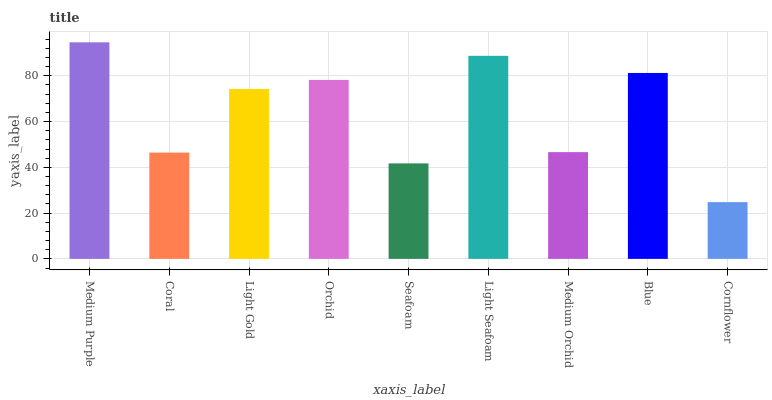Is Cornflower the minimum?
Answer yes or no. Yes. Is Medium Purple the maximum?
Answer yes or no. Yes. Is Coral the minimum?
Answer yes or no. No. Is Coral the maximum?
Answer yes or no. No. Is Medium Purple greater than Coral?
Answer yes or no. Yes. Is Coral less than Medium Purple?
Answer yes or no. Yes. Is Coral greater than Medium Purple?
Answer yes or no. No. Is Medium Purple less than Coral?
Answer yes or no. No. Is Light Gold the high median?
Answer yes or no. Yes. Is Light Gold the low median?
Answer yes or no. Yes. Is Medium Orchid the high median?
Answer yes or no. No. Is Light Seafoam the low median?
Answer yes or no. No. 